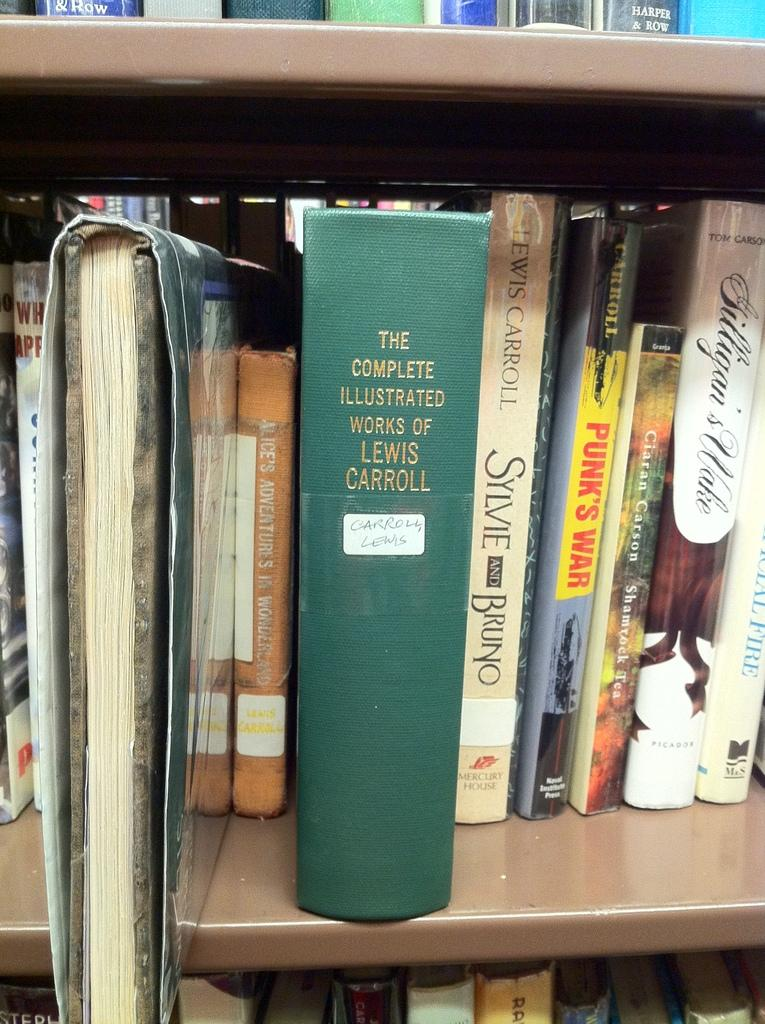<image>
Present a compact description of the photo's key features. The green book is called The Complete Illustrated Works of Lewis Carroll 